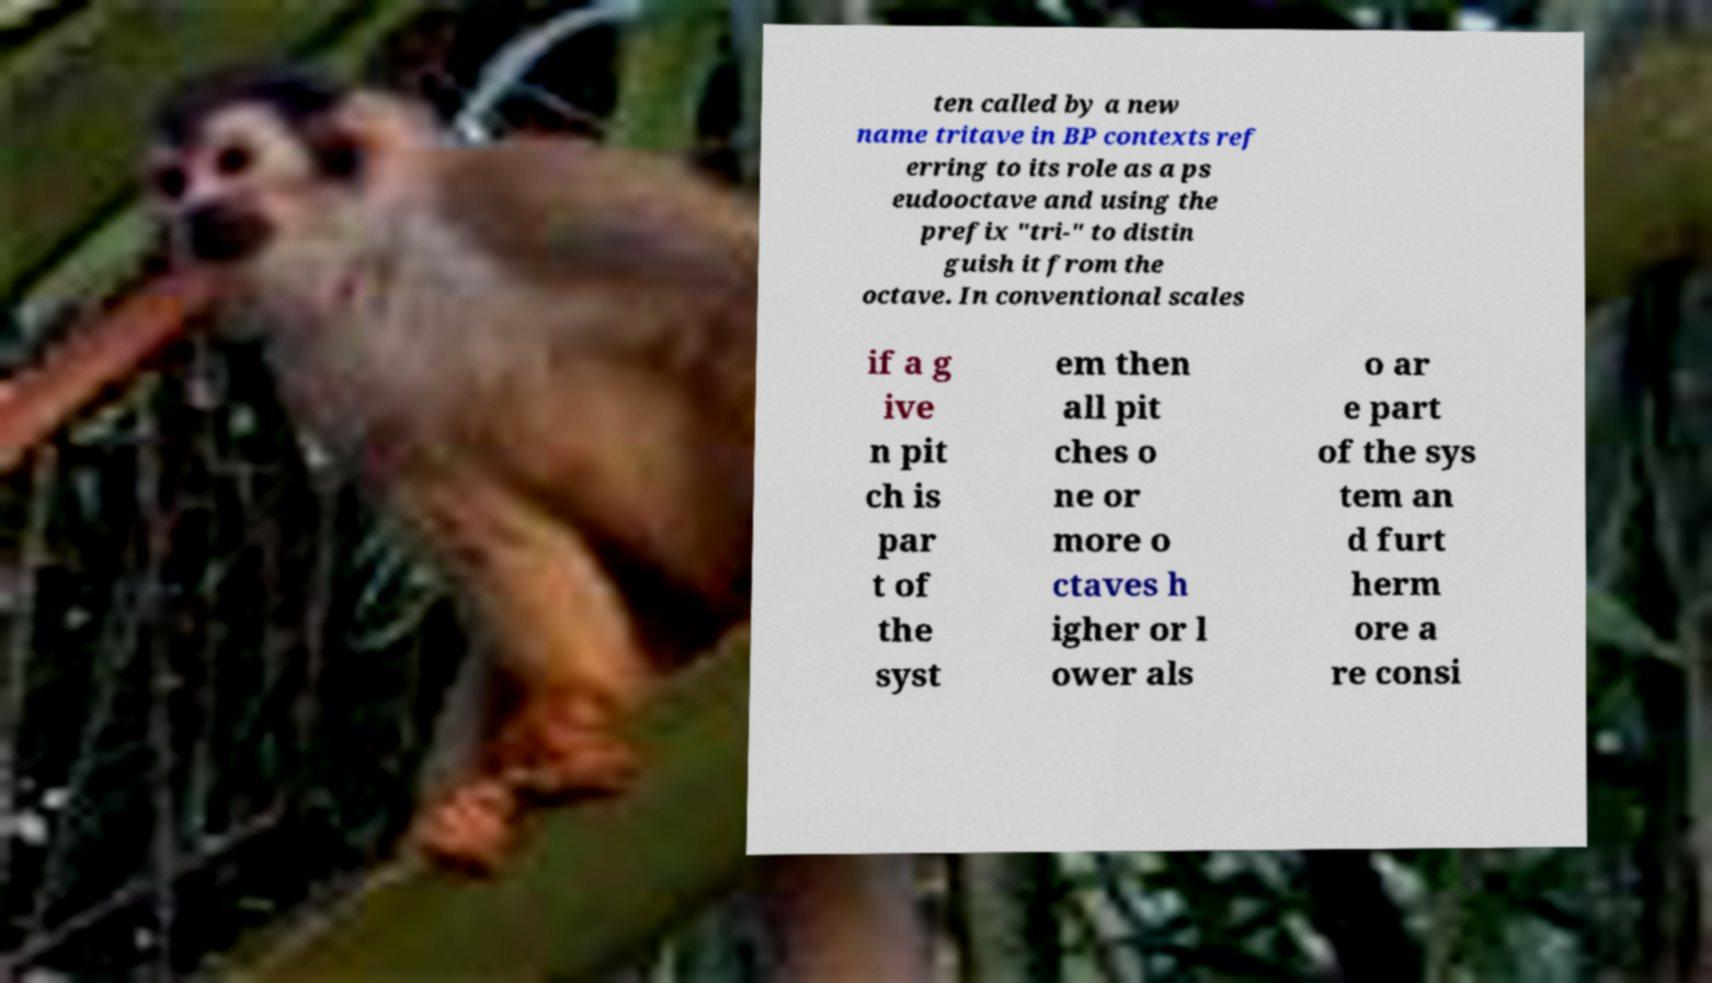Please read and relay the text visible in this image. What does it say? ten called by a new name tritave in BP contexts ref erring to its role as a ps eudooctave and using the prefix "tri-" to distin guish it from the octave. In conventional scales if a g ive n pit ch is par t of the syst em then all pit ches o ne or more o ctaves h igher or l ower als o ar e part of the sys tem an d furt herm ore a re consi 